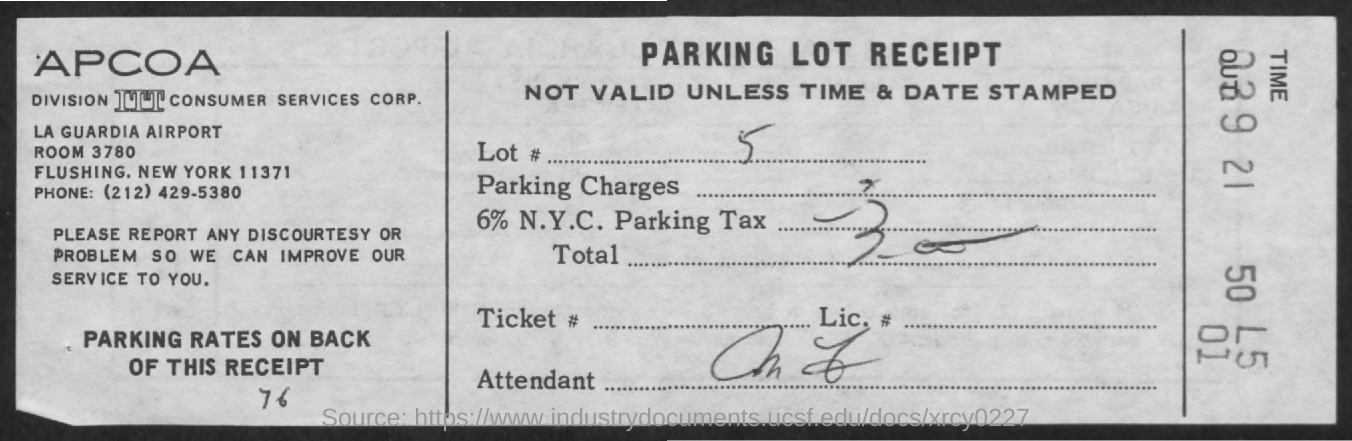What type of receipt is given here?
Keep it short and to the point. Parking lot receipt. What is the Lot #(no) given in the receipt?
Provide a short and direct response. 5. 